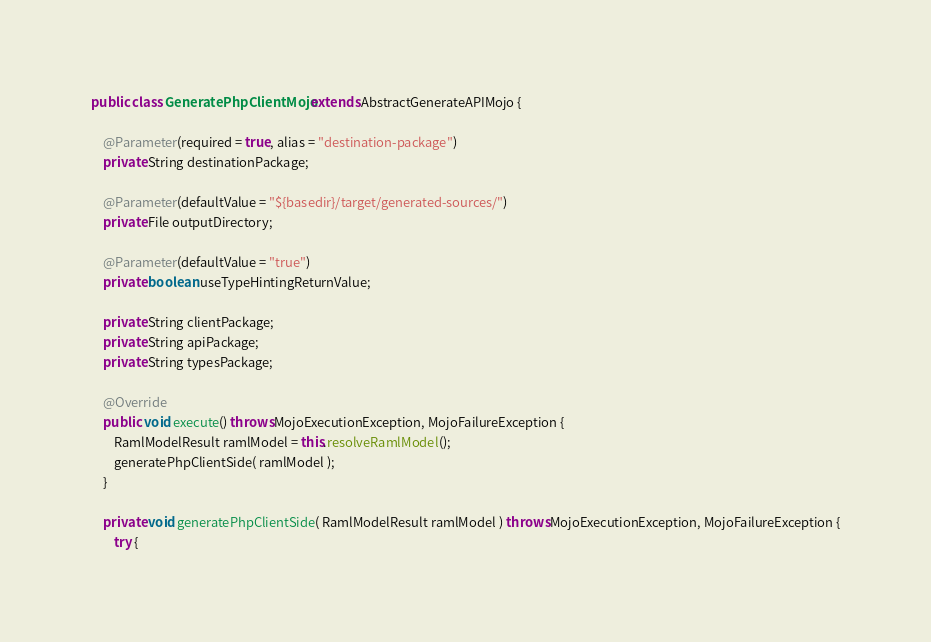<code> <loc_0><loc_0><loc_500><loc_500><_Java_>public class GeneratePhpClientMojo extends AbstractGenerateAPIMojo {

    @Parameter(required = true, alias = "destination-package")
    private String destinationPackage;

    @Parameter(defaultValue = "${basedir}/target/generated-sources/")
    private File outputDirectory;

    @Parameter(defaultValue = "true")
    private boolean useTypeHintingReturnValue;

    private String clientPackage;
    private String apiPackage;
    private String typesPackage;

    @Override
    public void execute() throws MojoExecutionException, MojoFailureException {
        RamlModelResult ramlModel = this.resolveRamlModel();
        generatePhpClientSide( ramlModel );
    }

    private void generatePhpClientSide( RamlModelResult ramlModel ) throws MojoExecutionException, MojoFailureException {
        try {</code> 